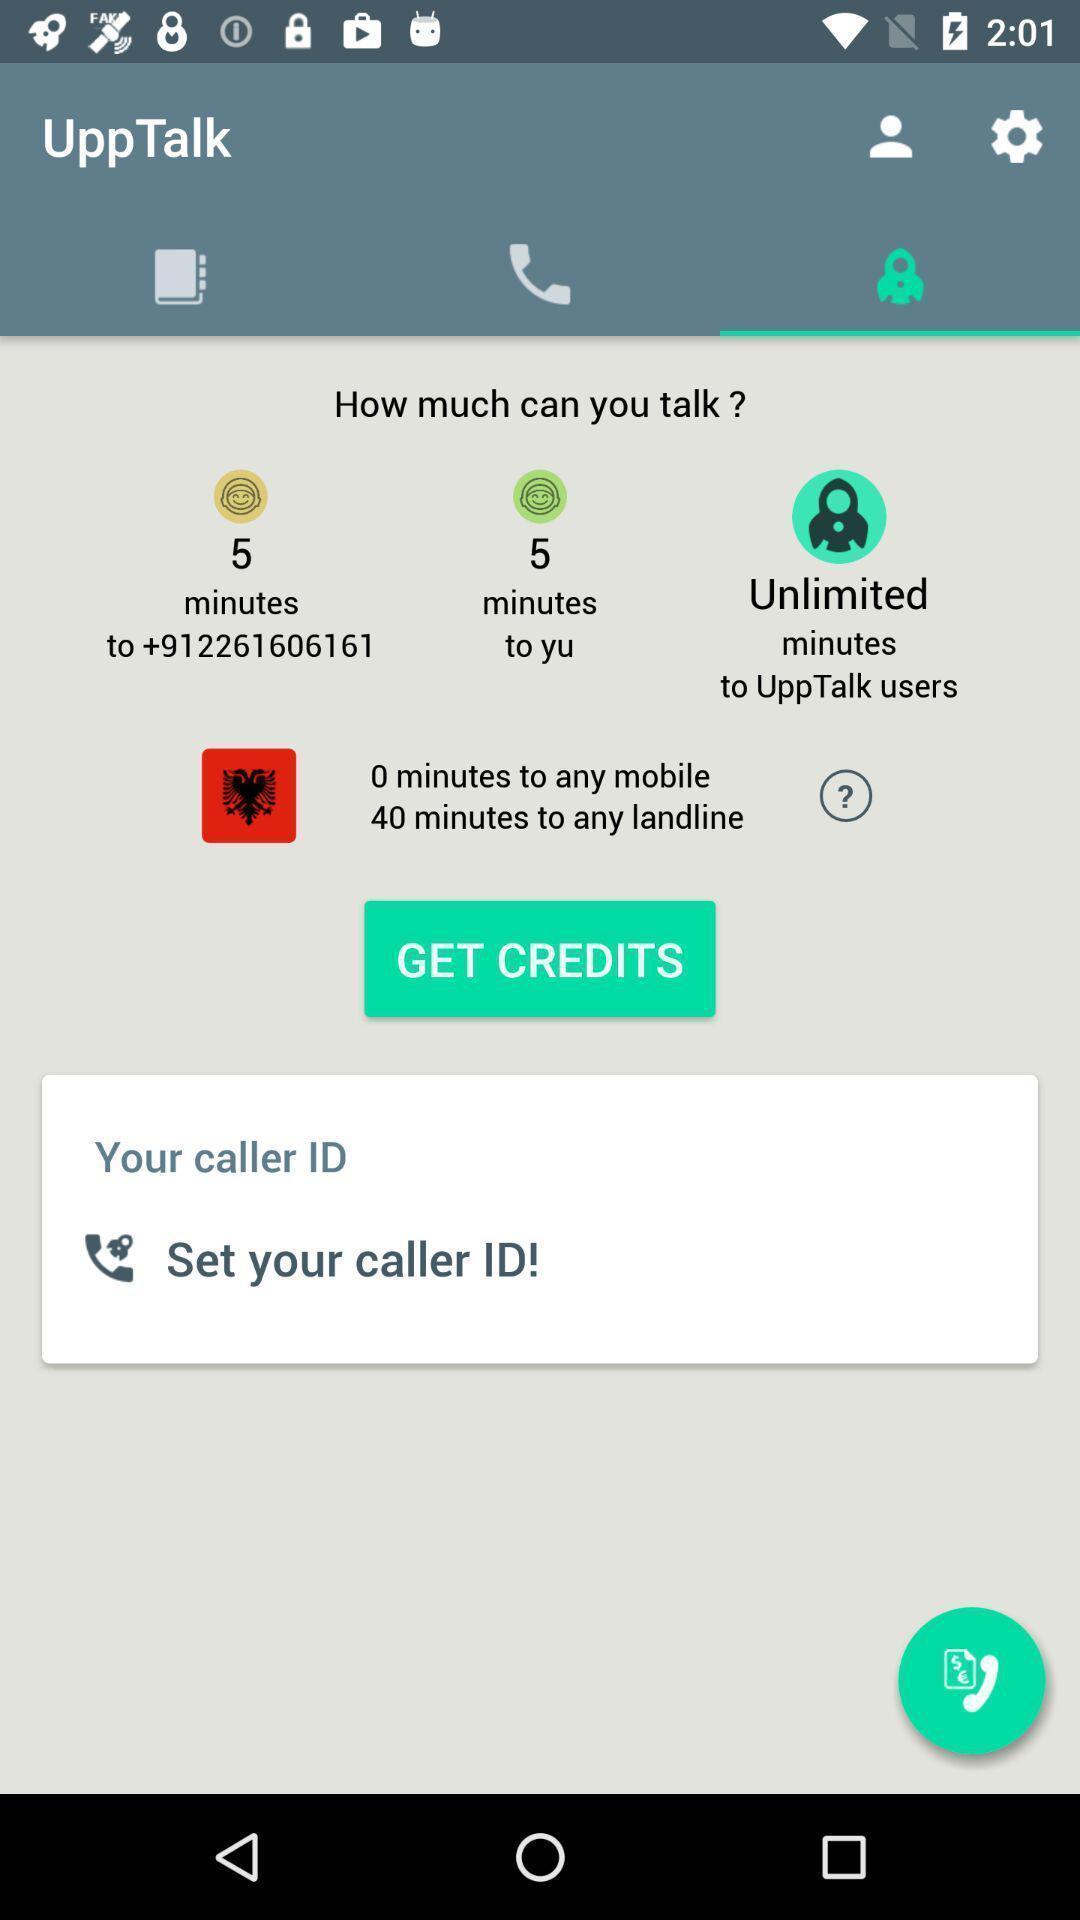Tell me about the visual elements in this screen capture. Page with credits in a communication app. 